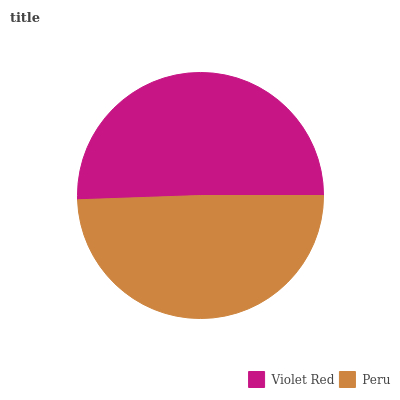Is Peru the minimum?
Answer yes or no. Yes. Is Violet Red the maximum?
Answer yes or no. Yes. Is Peru the maximum?
Answer yes or no. No. Is Violet Red greater than Peru?
Answer yes or no. Yes. Is Peru less than Violet Red?
Answer yes or no. Yes. Is Peru greater than Violet Red?
Answer yes or no. No. Is Violet Red less than Peru?
Answer yes or no. No. Is Violet Red the high median?
Answer yes or no. Yes. Is Peru the low median?
Answer yes or no. Yes. Is Peru the high median?
Answer yes or no. No. Is Violet Red the low median?
Answer yes or no. No. 